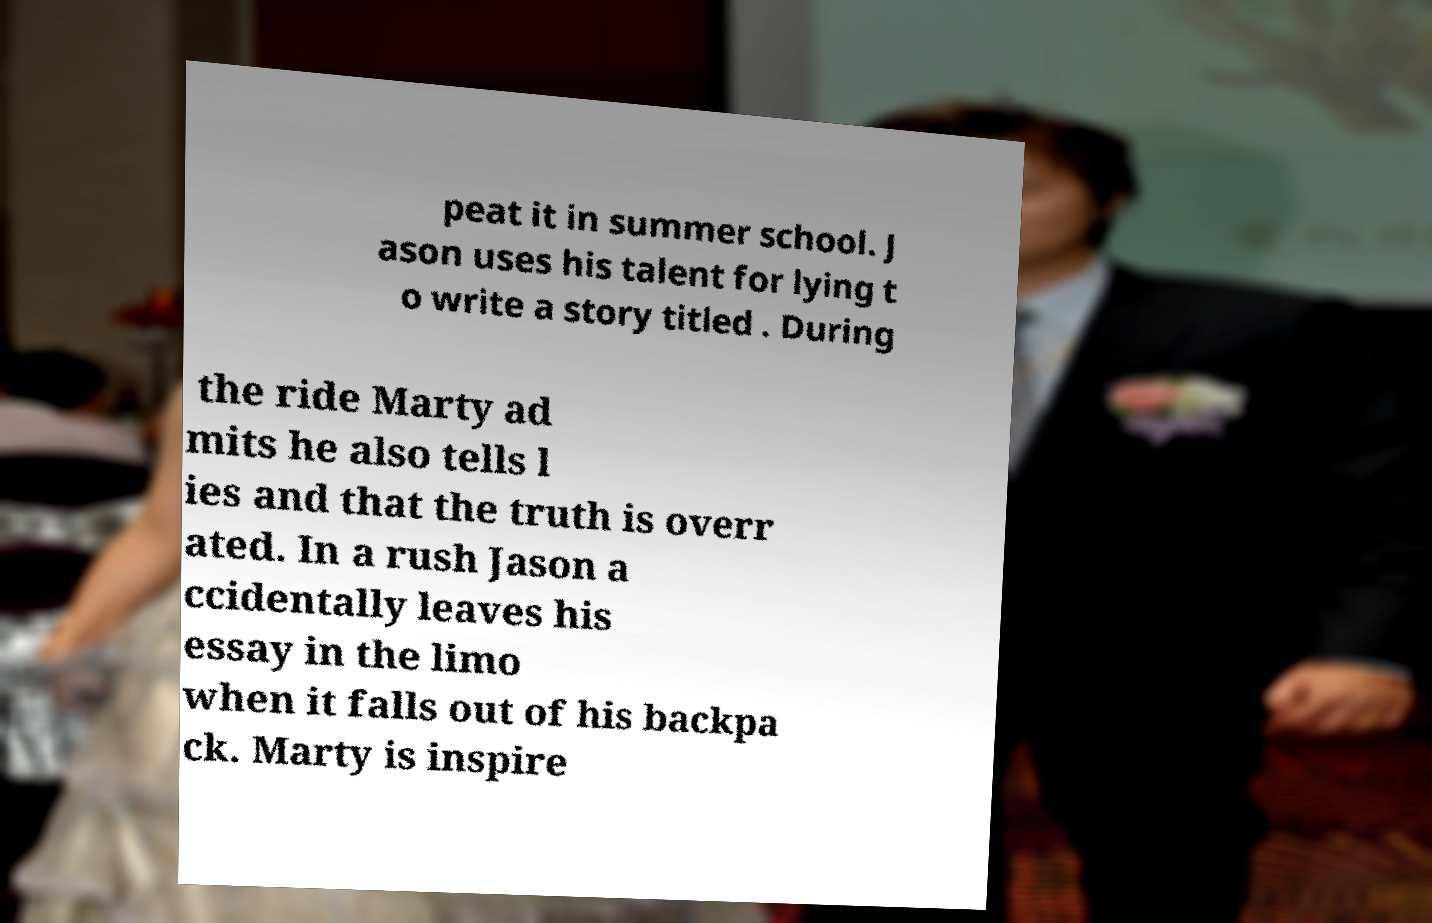Can you accurately transcribe the text from the provided image for me? peat it in summer school. J ason uses his talent for lying t o write a story titled . During the ride Marty ad mits he also tells l ies and that the truth is overr ated. In a rush Jason a ccidentally leaves his essay in the limo when it falls out of his backpa ck. Marty is inspire 